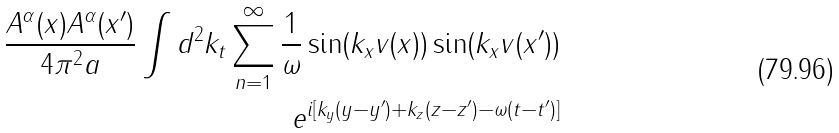<formula> <loc_0><loc_0><loc_500><loc_500>\frac { A ^ { \alpha } ( x ) A ^ { \alpha } ( x ^ { \prime } ) } { 4 \pi ^ { 2 } a } \int d ^ { 2 } k _ { t } \sum _ { n = 1 } ^ { \infty } \frac { 1 } { \omega } \sin ( k _ { x } v ( x ) ) \sin ( k _ { x } v ( x ^ { \prime } ) ) \\ e ^ { i [ k _ { y } ( y - y ^ { \prime } ) + k _ { z } ( z - z ^ { \prime } ) - \omega ( t - t ^ { \prime } ) ] }</formula> 